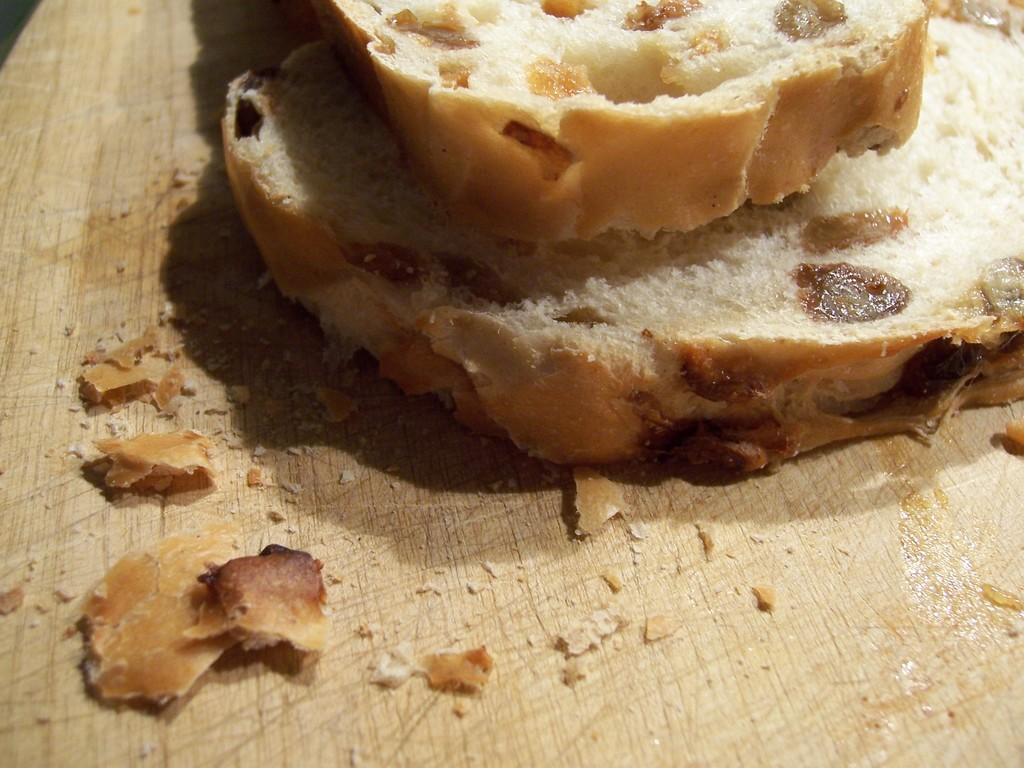What is placed on the table in the image? There is bread on a table in the image. Reasoning: Let' Let's think step by step in order to produce the conversation. We start by identifying the main subject in the image, which is the bread. Then, we formulate a question that focuses on the location of the bread, ensuring that the language is simple and clear. We avoid yes/no questions and ensure that the question can be answered definitively with the information given. Absurd Question/Answer: Is there a bike parked next to the table in the image? There is no mention of a bike in the image; it only states that there is bread on a table. Is there a tin of lettuce on the table in the image? There is no mention of a tin or lettuce in the image; it only states that there is bread on a table. 